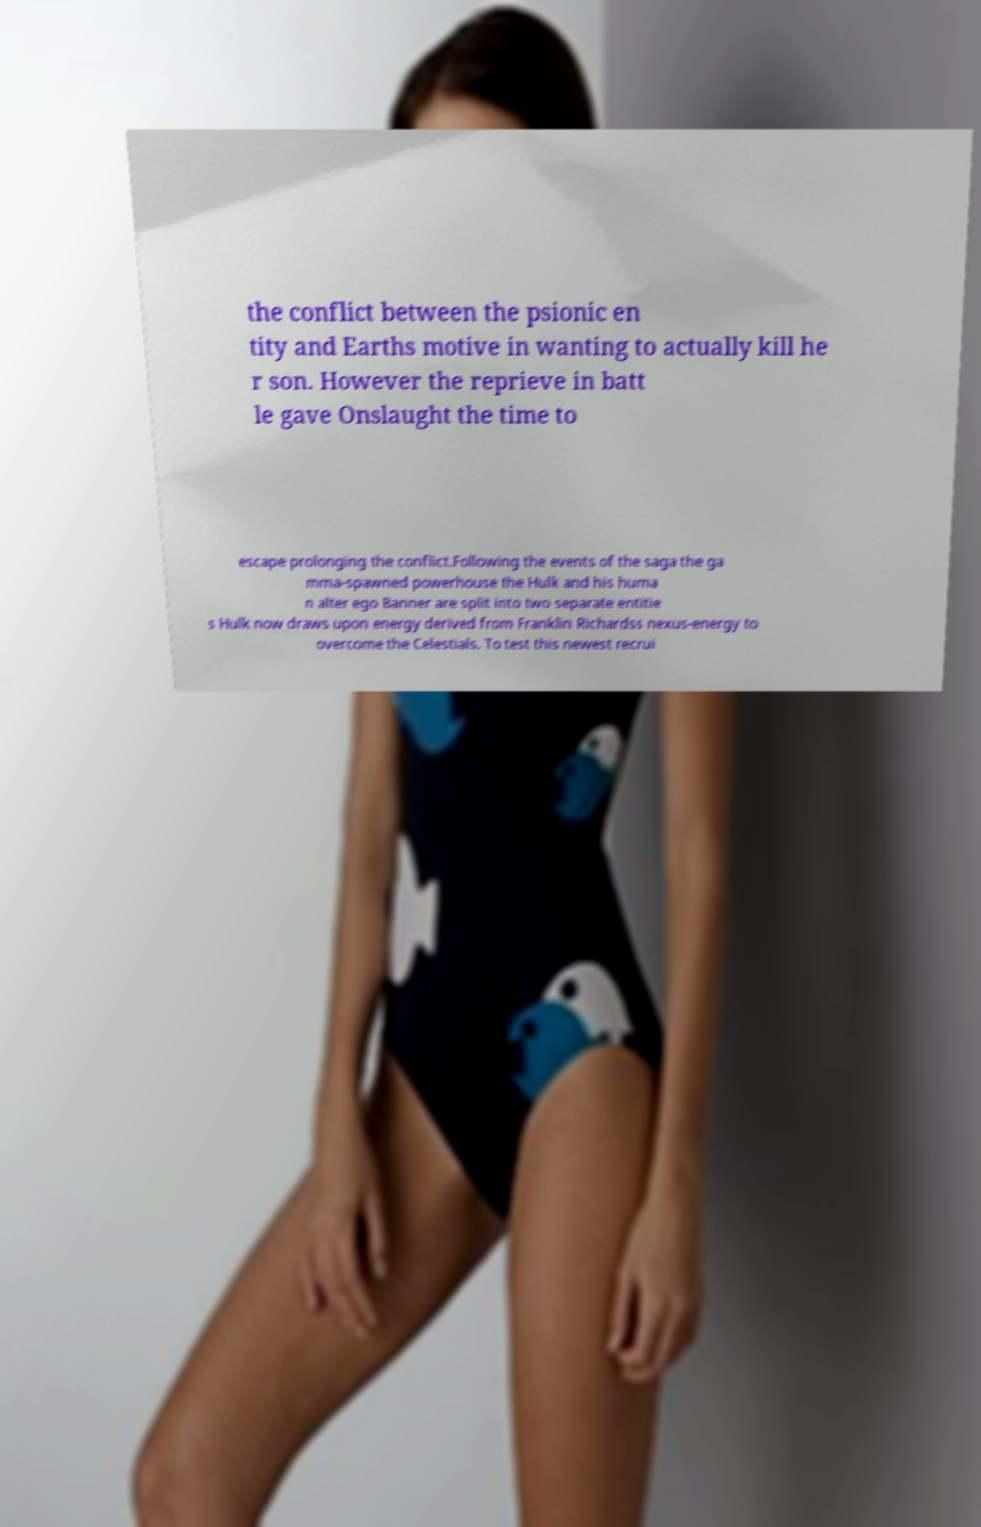Can you accurately transcribe the text from the provided image for me? the conflict between the psionic en tity and Earths motive in wanting to actually kill he r son. However the reprieve in batt le gave Onslaught the time to escape prolonging the conflict.Following the events of the saga the ga mma-spawned powerhouse the Hulk and his huma n alter ego Banner are split into two separate entitie s Hulk now draws upon energy derived from Franklin Richardss nexus-energy to overcome the Celestials. To test this newest recrui 